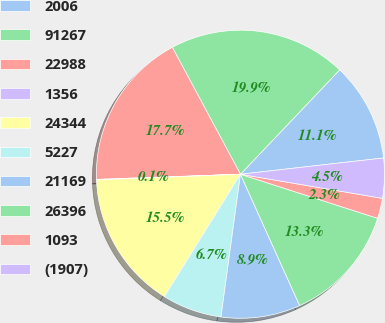Convert chart. <chart><loc_0><loc_0><loc_500><loc_500><pie_chart><fcel>2006<fcel>91267<fcel>22988<fcel>1356<fcel>24344<fcel>5227<fcel>21169<fcel>26396<fcel>1093<fcel>(1907)<nl><fcel>11.1%<fcel>19.94%<fcel>17.73%<fcel>0.06%<fcel>15.52%<fcel>6.69%<fcel>8.9%<fcel>13.31%<fcel>2.27%<fcel>4.48%<nl></chart> 